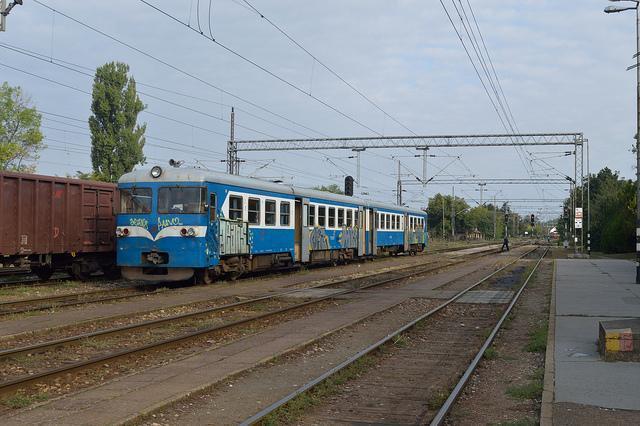How many sets of tracks are there?
Give a very brief answer. 4. How many different trains are on the tracks?
Give a very brief answer. 2. How many tracks are seen?
Give a very brief answer. 3. How many cars does the train have?
Give a very brief answer. 4. How many cars on this train?
Give a very brief answer. 4. How many tracks are there?
Give a very brief answer. 4. How many trains are there?
Give a very brief answer. 2. 